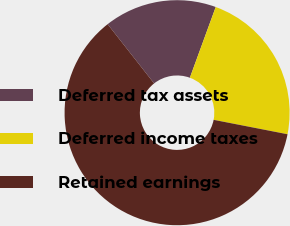Convert chart to OTSL. <chart><loc_0><loc_0><loc_500><loc_500><pie_chart><fcel>Deferred tax assets<fcel>Deferred income taxes<fcel>Retained earnings<nl><fcel>16.17%<fcel>22.49%<fcel>61.34%<nl></chart> 